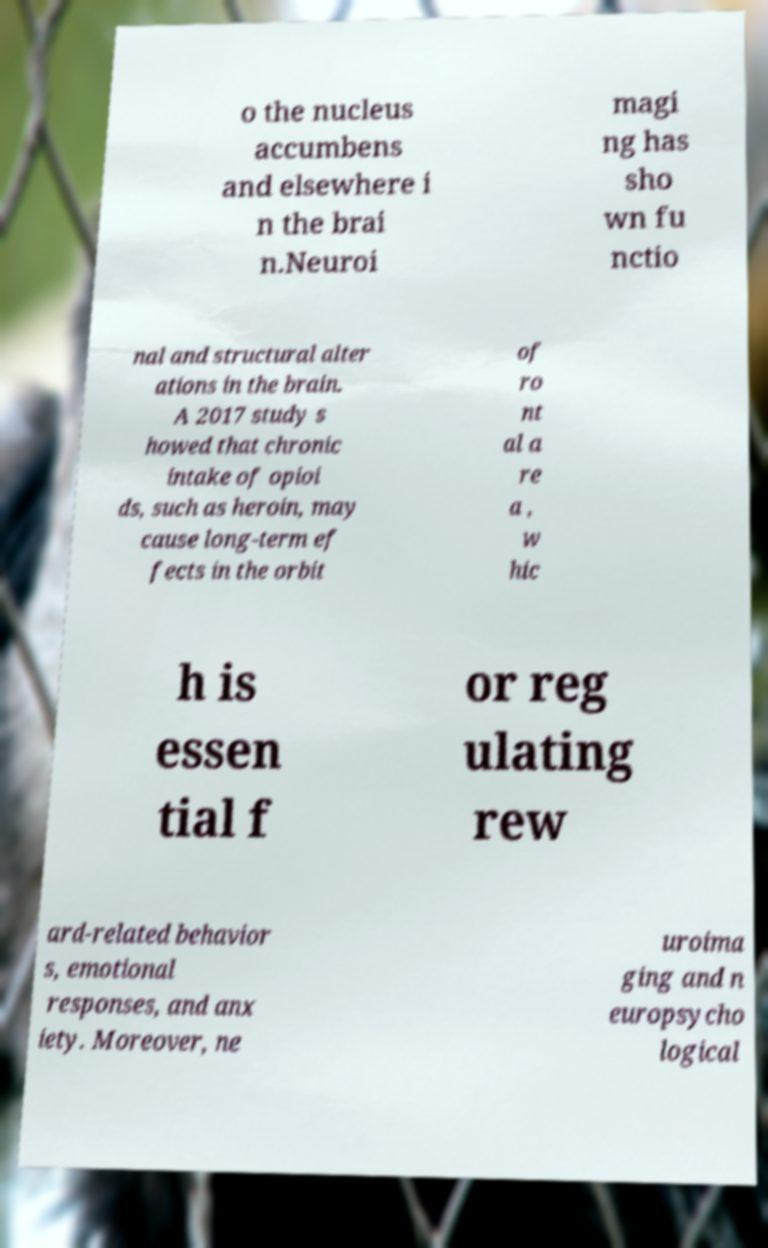For documentation purposes, I need the text within this image transcribed. Could you provide that? o the nucleus accumbens and elsewhere i n the brai n.Neuroi magi ng has sho wn fu nctio nal and structural alter ations in the brain. A 2017 study s howed that chronic intake of opioi ds, such as heroin, may cause long-term ef fects in the orbit of ro nt al a re a , w hic h is essen tial f or reg ulating rew ard-related behavior s, emotional responses, and anx iety. Moreover, ne uroima ging and n europsycho logical 